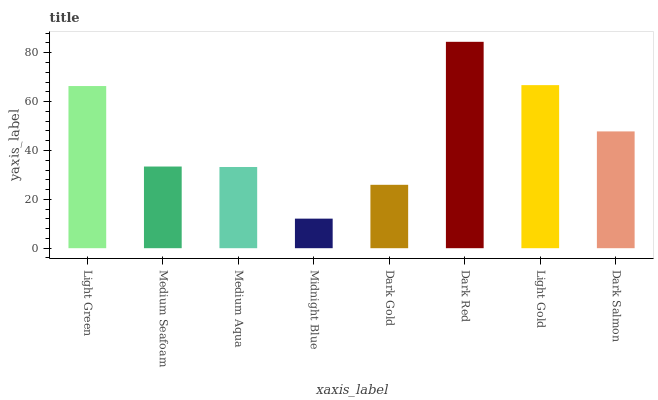Is Midnight Blue the minimum?
Answer yes or no. Yes. Is Dark Red the maximum?
Answer yes or no. Yes. Is Medium Seafoam the minimum?
Answer yes or no. No. Is Medium Seafoam the maximum?
Answer yes or no. No. Is Light Green greater than Medium Seafoam?
Answer yes or no. Yes. Is Medium Seafoam less than Light Green?
Answer yes or no. Yes. Is Medium Seafoam greater than Light Green?
Answer yes or no. No. Is Light Green less than Medium Seafoam?
Answer yes or no. No. Is Dark Salmon the high median?
Answer yes or no. Yes. Is Medium Seafoam the low median?
Answer yes or no. Yes. Is Light Gold the high median?
Answer yes or no. No. Is Dark Salmon the low median?
Answer yes or no. No. 